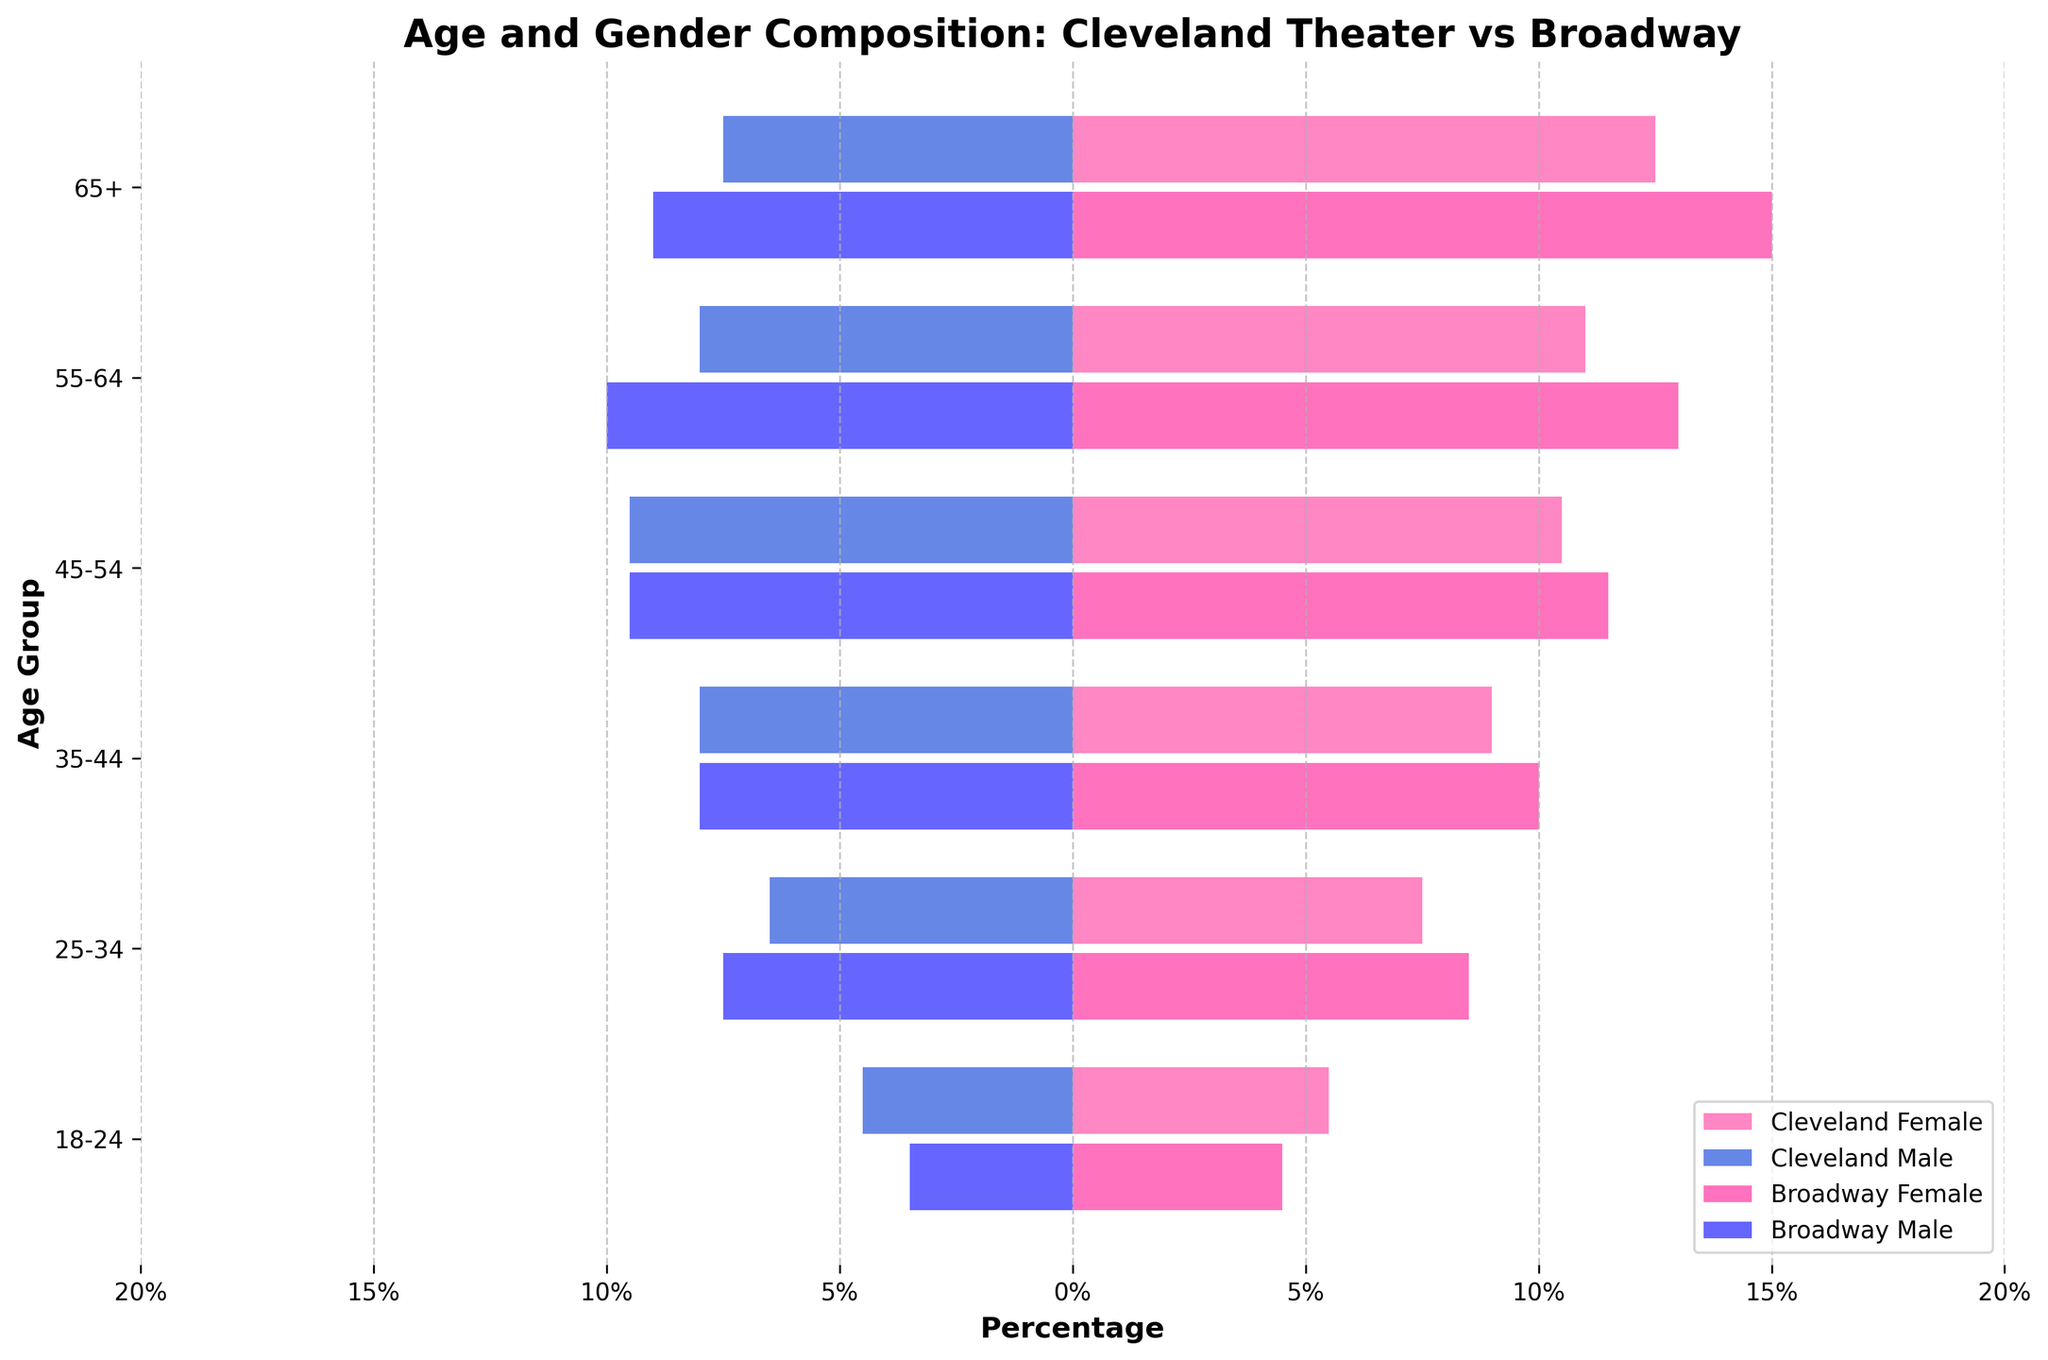How many age groups are represented in the figure? The y-axis lists the age groups. By counting the different labels on the y-axis, we can determine the number of age groups. There are 6 age groups ("65+", "55-64", "45-54", "35-44", "25-34", and "18-24").
Answer: 6 What is the title of the figure? The title of the figure is typically displayed at the top of the plot. By reading the text at the top, it's titled "Age and Gender Composition: Cleveland Theater vs Broadway".
Answer: Age and Gender Composition: Cleveland Theater vs Broadway Which age group has the highest percentage of female attendees for Cleveland Theater? By observing the bar lengths for the pink bars (representing female attendees for Cleveland Theater) across different age groups, the "65+" group has the longest bar at 12.5%.
Answer: 65+ What are the colors used to represent Cleveland male and Broadway male attendees, respectively? The colors are visible through the legend and the bars on the plot. Cleveland male attendees are represented with blue, while Broadway male attendees are represented with a slightly darker blue.
Answer: Blue, Dark Blue Compare the percentages of male attendees aged 55-64 between Cleveland Theater and Broadway. Which is higher? The bars representing male attendees aged 55-64 should be compared. The Cleveland Theater has a male percentage of 8%, while Broadway has a male percentage of 10%. Broadway's percentage is higher.
Answer: Broadway Calculate the total percentage of attendees aged 35-44 for both genders in Cleveland Theater. To find the total, add the percentages of male and female attendees for this age group in Cleveland Theater: 9.0% (female) + 8.0% (male) = 17.0%.
Answer: 17.0% Is the percentage of Broadway female attendees higher or lower than Cleveland female attendees in the 18-24 age group? By comparing the pink bars representing female attendees for both Broadway and Cleveland in the 18-24 age group, Broadway has 4.5% while Cleveland has 5.5%. Broadway is lower.
Answer: Lower Which age group has the smallest difference between the percentage of male attendees for Cleveland Theater and Broadway? Find the differences between male percentages for all age groups, then identify the smallest difference. The 18-24 age group has the smallest difference: 4.5% (Cleveland) - 3.5% (Broadway) = 1%.
Answer: 18-24 What is the total percentage of Cleveland attendees aged 65+ when combining both genders? Add the percentage of female and male attendees for the 65+ age group in Cleveland: 12.5% (female) + 7.5% (male) = 20.0%.
Answer: 20.0% In the 45-54 age group, which gender has a higher percentage of attendees in both Broadway and Cleveland Theater? Compare the percentages of male and female attendees in both Cleveland and Broadway for the 45-54 age group. Cleveland: 10.5% (female) vs 9.5% (male). Broadway: 11.5% (female) vs 9.5% (male). Females have a higher percentage in both cases.
Answer: Female 